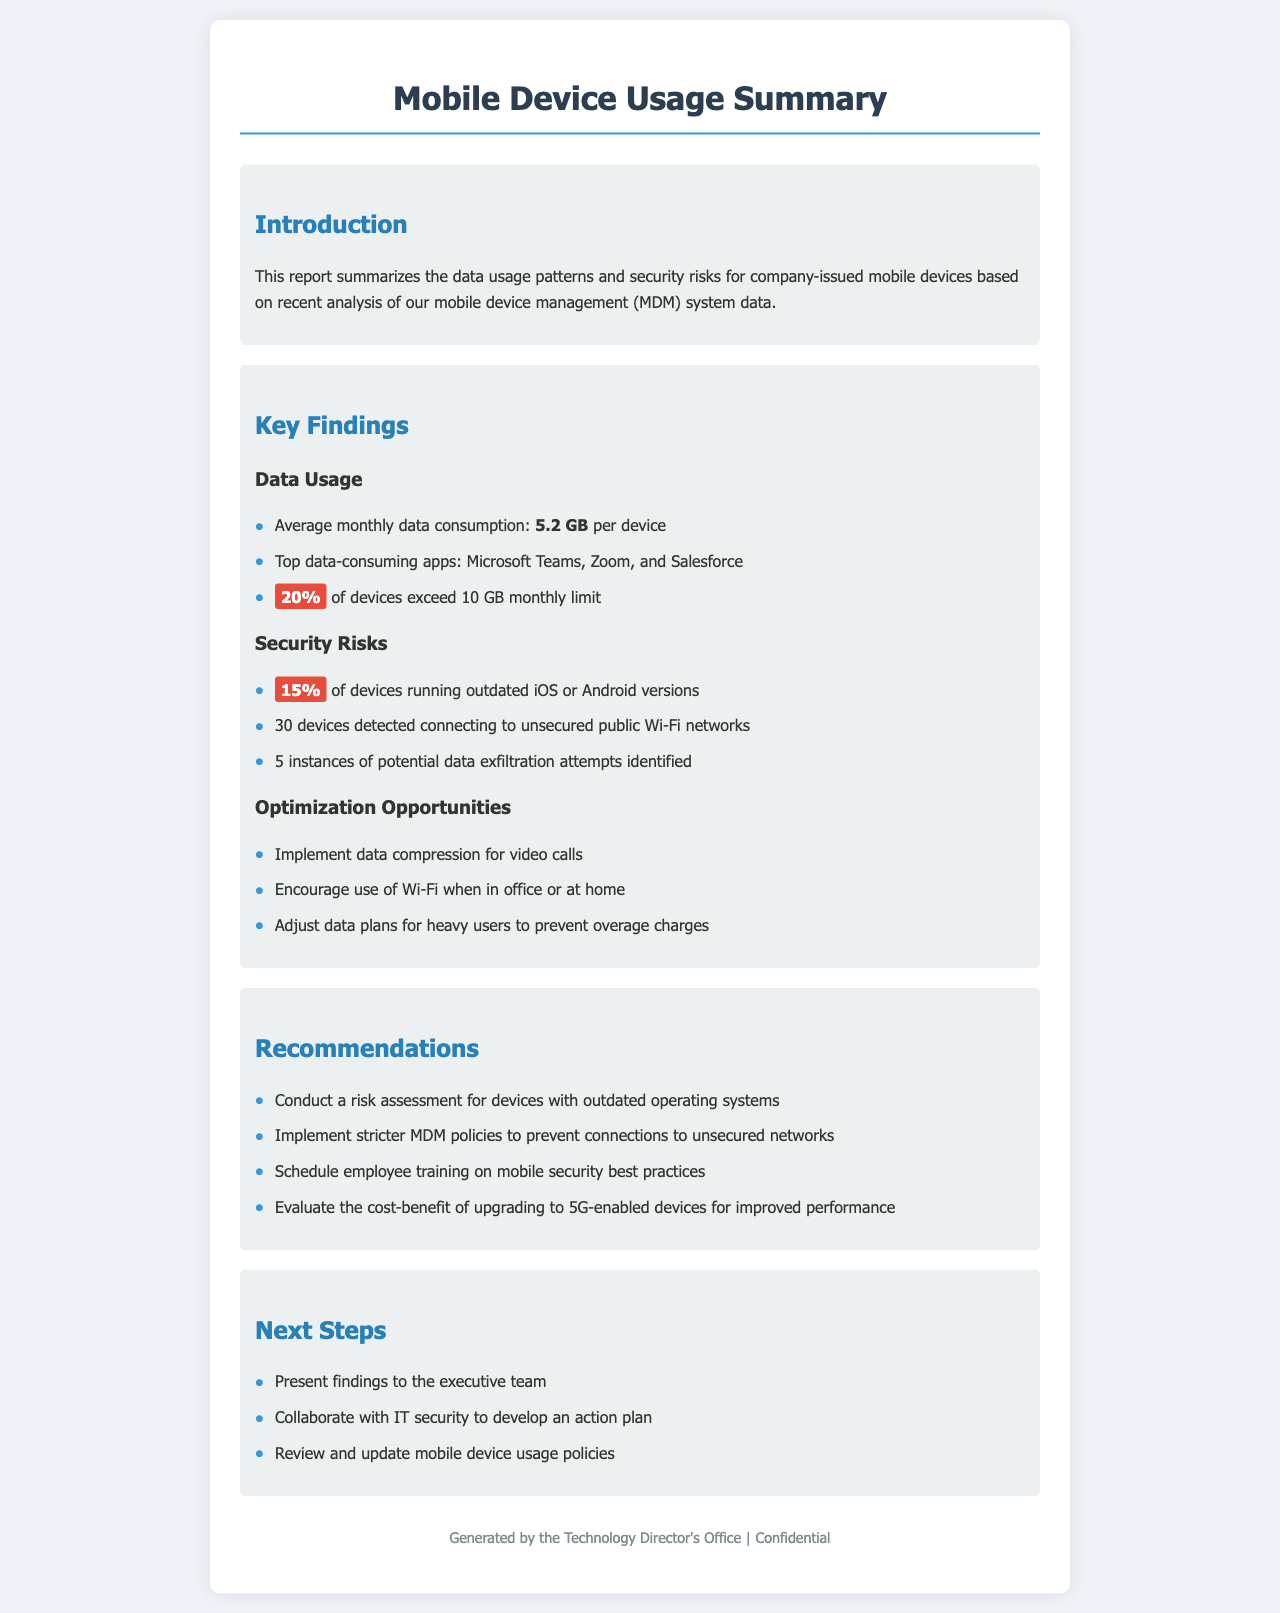What is the average monthly data consumption per device? The average monthly data consumption per device is stated clearly in the key findings section of the document.
Answer: 5.2 GB What percentage of devices exceed the monthly limit of 10 GB? The document specifies this percentage in relation to device usage patterns.
Answer: 20% How many devices are detected connecting to unsecured public Wi-Fi networks? This information is provided under the security risks section.
Answer: 30 devices What is the percentage of devices running outdated operating systems? The document provides a specific percentage related to security risks.
Answer: 15% What is one of the top data-consuming apps mentioned? The report lists certain applications as top data consumers; one is explicitly named.
Answer: Microsoft Teams What is a recommended action for devices with outdated operating systems? The recommendations section suggests a specific action regarding outdated systems.
Answer: Conduct a risk assessment What is suggested to optimize data usage during video calls? The document provides a specific measure to improve data consumption during video calls.
Answer: Implement data compression What type of training is recommended for employees? The recommendations section mentions a specific type of training to enhance security awareness.
Answer: Mobile security best practices 